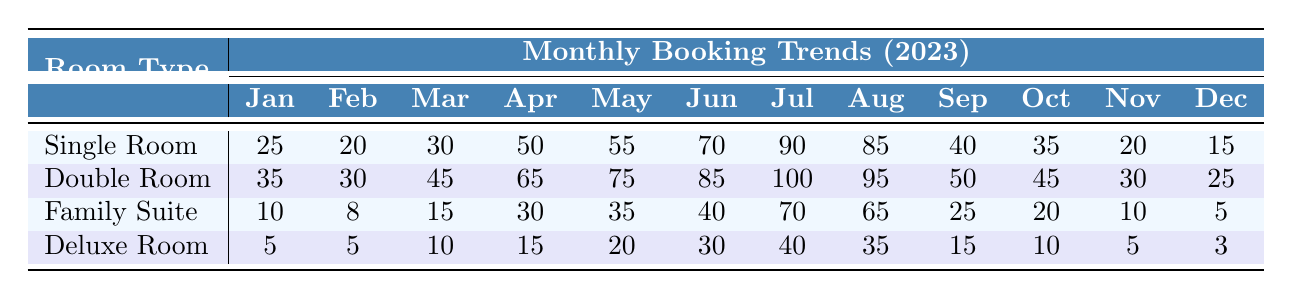What's the total number of bookings for Single Rooms in July? According to the table, the number of bookings for Single Rooms in July is 90.
Answer: 90 How many more bookings did Double Rooms have compared to Family Suites in April? In April, Double Rooms had 65 bookings and Family Suites had 30 bookings. The difference is 65 - 30 = 35.
Answer: 35 What is the average monthly booking for Deluxe Rooms across the year? The total bookings for Deluxe Rooms are (5 + 5 + 10 + 15 + 20 + 30 + 40 + 35 + 15 + 10 + 5 + 3) = 173. Dividing this by 12 months results in an average of 173 / 12 = 14.42, which rounds down to 14 when considering whole bookings.
Answer: 14 In which month did Family Suites see their highest bookings? Checking the table, Family Suites had their highest booking in July with 70 bookings.
Answer: July Did the bookings for Double Rooms decline between September and October? Yes, the bookings for Double Rooms in September were 50, and in October they decreased to 45, indicating a decline.
Answer: Yes What is the total number of bookings for all room types in December? Summing the bookings in December for all room types: Single Room (15) + Double Room (25) + Family Suite (5) + Deluxe Room (3) gives 48 total bookings.
Answer: 48 Which room type had the least number of total bookings in the year? By calculating total bookings, we find Single Rooms: 480, Double Rooms: 570, Family Suites: 250, Deluxe Rooms: 158. Therefore, Deluxe Rooms had the least bookings.
Answer: Deluxe Room What was the percentage increase in bookings for Single Rooms from May to June? The bookings increased from 55 in May to 70 in June. The increase is 70 - 55 = 15. To find the percentage increase, divide by May's bookings: (15 / 55) x 100 = 27.27%.
Answer: 27.27% In which month did Deluxe Rooms have the highest bookings? Looking at the table, Deluxe Rooms peaked in July with 40 bookings.
Answer: July Is it true that the booking numbers for Family Suites were consistently lower than for Double Rooms throughout the year? Analyzing the data, Family Suites were lower than Double Rooms in every month, confirming the statement is true.
Answer: Yes 